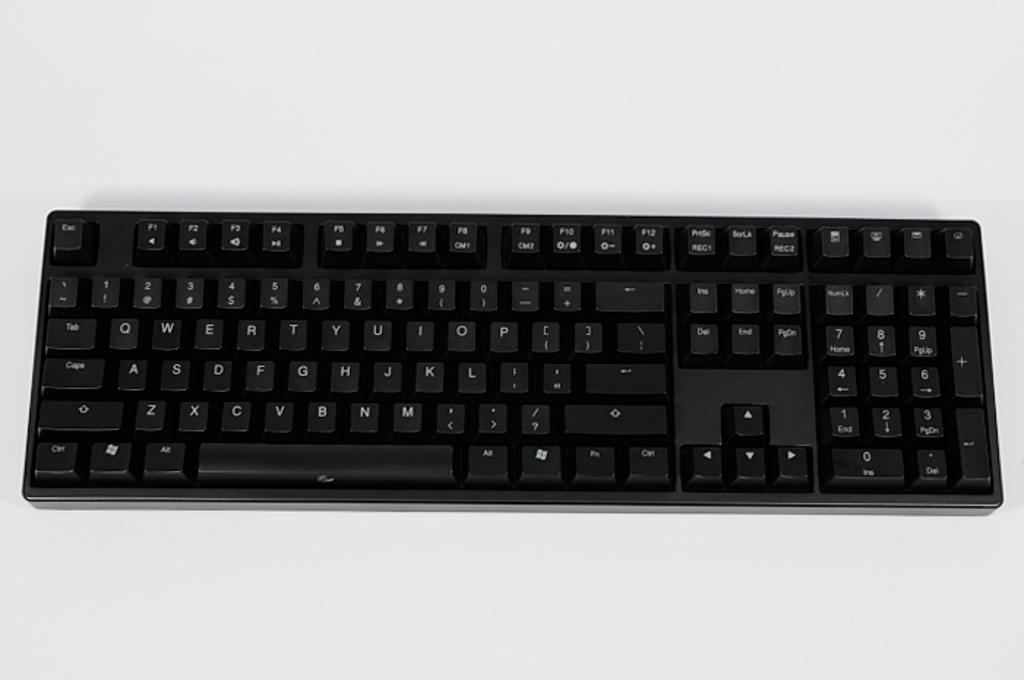<image>
Render a clear and concise summary of the photo. Standard black keyboard with an ESC button on the top left. 